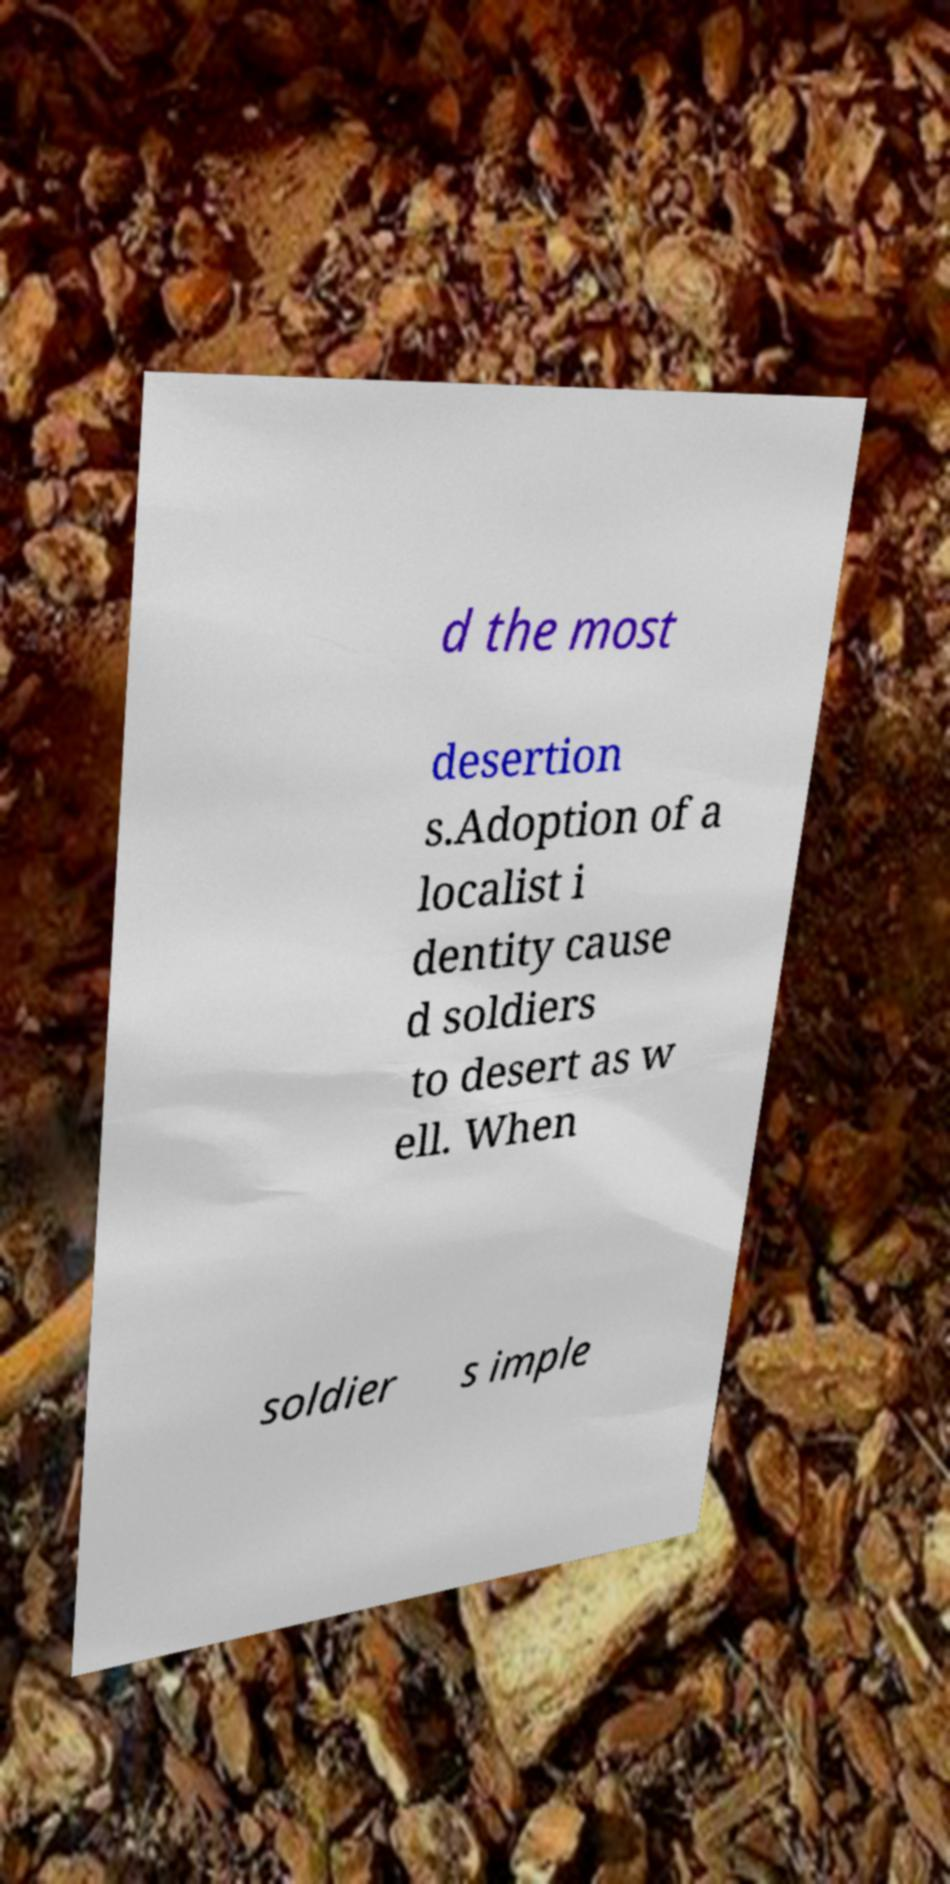Could you assist in decoding the text presented in this image and type it out clearly? d the most desertion s.Adoption of a localist i dentity cause d soldiers to desert as w ell. When soldier s imple 